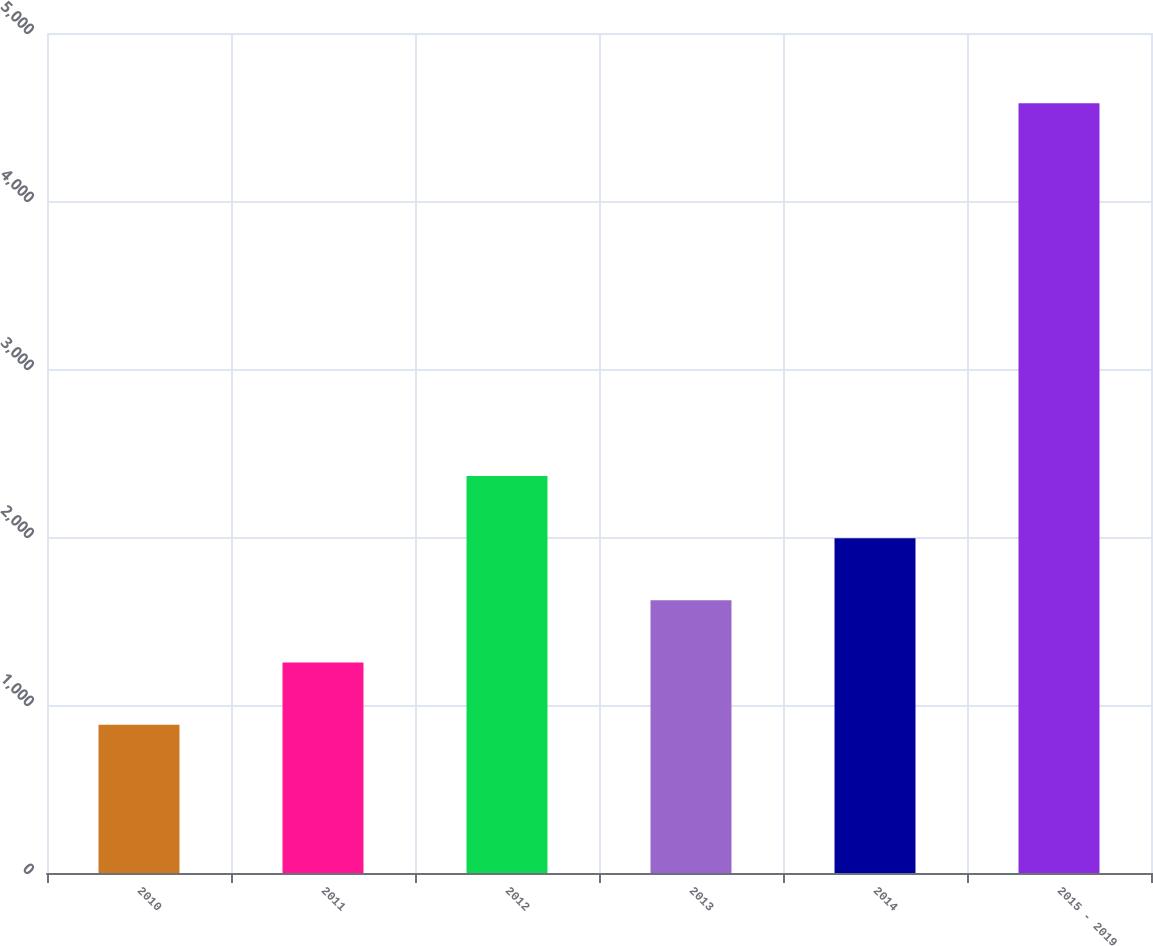Convert chart to OTSL. <chart><loc_0><loc_0><loc_500><loc_500><bar_chart><fcel>2010<fcel>2011<fcel>2012<fcel>2013<fcel>2014<fcel>2015 - 2019<nl><fcel>883<fcel>1252.9<fcel>2362.6<fcel>1622.8<fcel>1992.7<fcel>4582<nl></chart> 